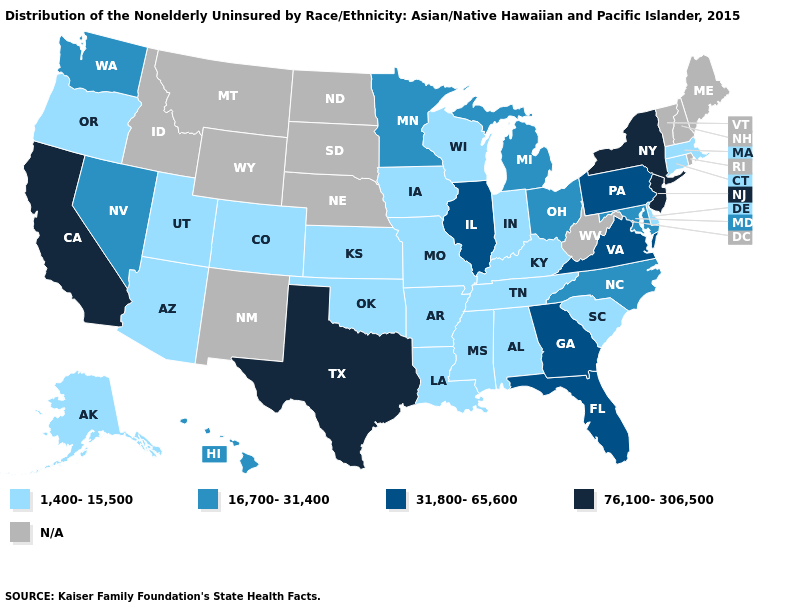What is the value of Tennessee?
Write a very short answer. 1,400-15,500. Name the states that have a value in the range N/A?
Concise answer only. Idaho, Maine, Montana, Nebraska, New Hampshire, New Mexico, North Dakota, Rhode Island, South Dakota, Vermont, West Virginia, Wyoming. Which states hav the highest value in the West?
Be succinct. California. Name the states that have a value in the range 1,400-15,500?
Be succinct. Alabama, Alaska, Arizona, Arkansas, Colorado, Connecticut, Delaware, Indiana, Iowa, Kansas, Kentucky, Louisiana, Massachusetts, Mississippi, Missouri, Oklahoma, Oregon, South Carolina, Tennessee, Utah, Wisconsin. What is the value of Missouri?
Keep it brief. 1,400-15,500. Among the states that border New York , does New Jersey have the highest value?
Write a very short answer. Yes. What is the value of Nevada?
Keep it brief. 16,700-31,400. Among the states that border Virginia , does Kentucky have the highest value?
Concise answer only. No. Among the states that border Ohio , which have the highest value?
Answer briefly. Pennsylvania. Does Oklahoma have the lowest value in the South?
Short answer required. Yes. What is the value of Alabama?
Short answer required. 1,400-15,500. Is the legend a continuous bar?
Give a very brief answer. No. Name the states that have a value in the range N/A?
Short answer required. Idaho, Maine, Montana, Nebraska, New Hampshire, New Mexico, North Dakota, Rhode Island, South Dakota, Vermont, West Virginia, Wyoming. What is the lowest value in the USA?
Keep it brief. 1,400-15,500. What is the highest value in the MidWest ?
Keep it brief. 31,800-65,600. 